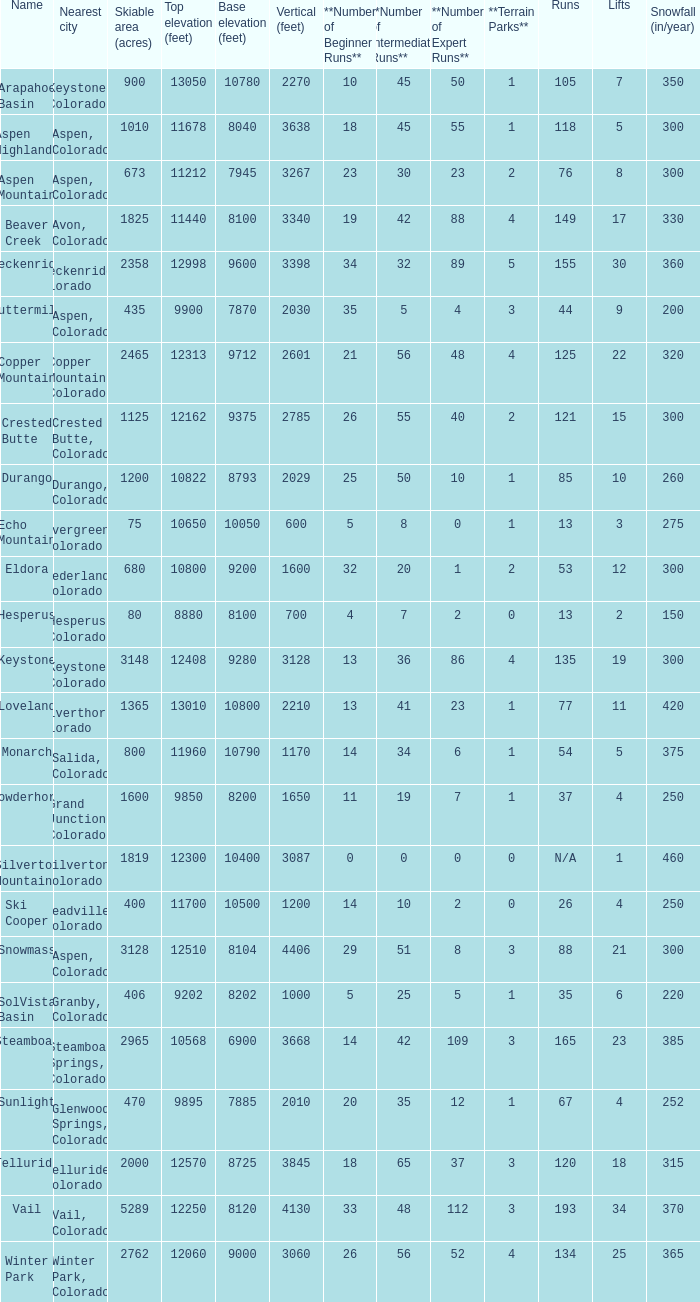If there are 30 lifts, what is the name of the ski resort? Breckenridge. 